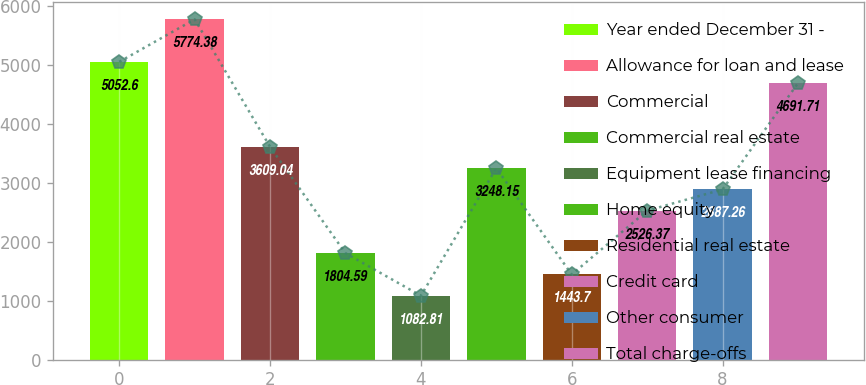Convert chart to OTSL. <chart><loc_0><loc_0><loc_500><loc_500><bar_chart><fcel>Year ended December 31 -<fcel>Allowance for loan and lease<fcel>Commercial<fcel>Commercial real estate<fcel>Equipment lease financing<fcel>Home equity<fcel>Residential real estate<fcel>Credit card<fcel>Other consumer<fcel>Total charge-offs<nl><fcel>5052.6<fcel>5774.38<fcel>3609.04<fcel>1804.59<fcel>1082.81<fcel>3248.15<fcel>1443.7<fcel>2526.37<fcel>2887.26<fcel>4691.71<nl></chart> 